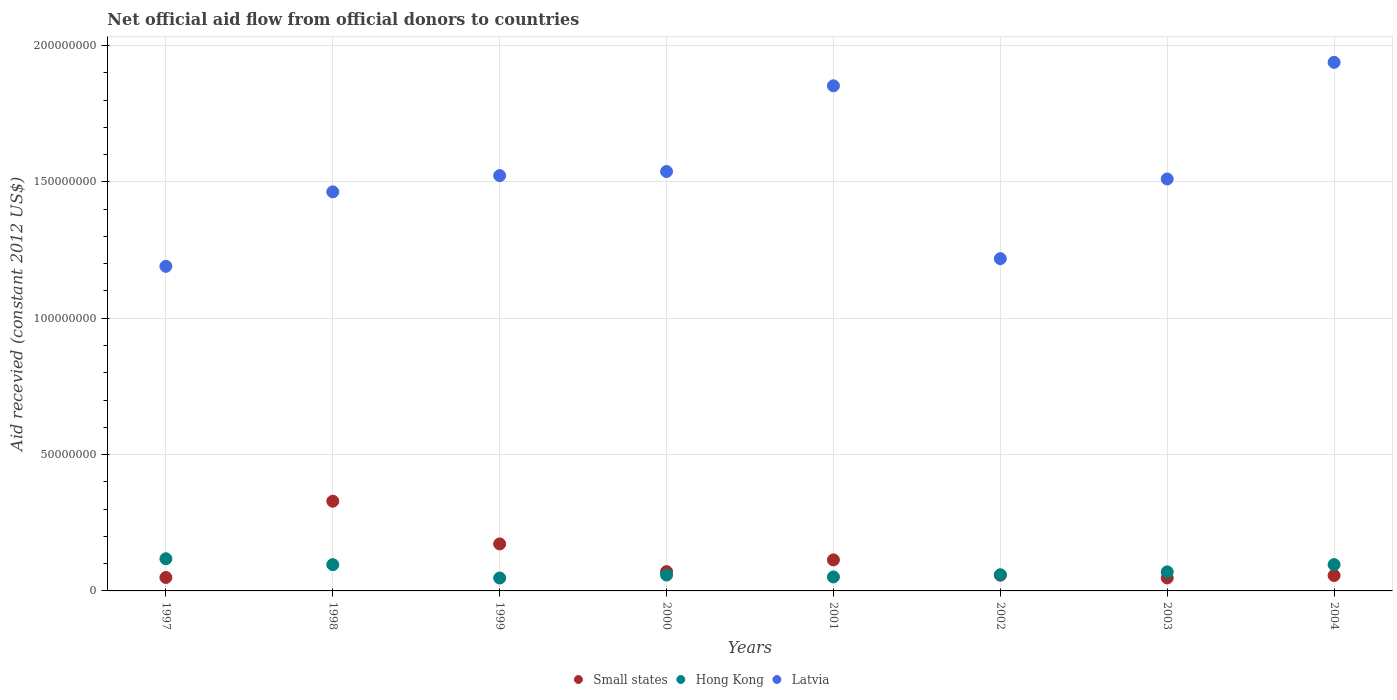How many different coloured dotlines are there?
Offer a very short reply. 3. What is the total aid received in Hong Kong in 2003?
Make the answer very short. 6.99e+06. Across all years, what is the maximum total aid received in Small states?
Your response must be concise. 3.29e+07. Across all years, what is the minimum total aid received in Small states?
Provide a short and direct response. 4.76e+06. In which year was the total aid received in Hong Kong maximum?
Offer a terse response. 1997. In which year was the total aid received in Latvia minimum?
Keep it short and to the point. 1997. What is the total total aid received in Small states in the graph?
Your answer should be compact. 8.97e+07. What is the difference between the total aid received in Latvia in 1997 and that in 2000?
Provide a succinct answer. -3.48e+07. What is the difference between the total aid received in Small states in 2002 and the total aid received in Latvia in 2001?
Make the answer very short. -1.79e+08. What is the average total aid received in Hong Kong per year?
Your answer should be compact. 7.46e+06. In the year 2002, what is the difference between the total aid received in Hong Kong and total aid received in Latvia?
Provide a short and direct response. -1.16e+08. In how many years, is the total aid received in Latvia greater than 180000000 US$?
Keep it short and to the point. 2. What is the ratio of the total aid received in Latvia in 2001 to that in 2003?
Offer a very short reply. 1.23. What is the difference between the highest and the second highest total aid received in Hong Kong?
Your answer should be very brief. 2.15e+06. What is the difference between the highest and the lowest total aid received in Small states?
Your answer should be compact. 2.81e+07. Is the sum of the total aid received in Small states in 2002 and 2003 greater than the maximum total aid received in Hong Kong across all years?
Make the answer very short. No. Is it the case that in every year, the sum of the total aid received in Small states and total aid received in Hong Kong  is greater than the total aid received in Latvia?
Provide a short and direct response. No. Is the total aid received in Latvia strictly greater than the total aid received in Small states over the years?
Keep it short and to the point. Yes. How many years are there in the graph?
Your answer should be very brief. 8. Are the values on the major ticks of Y-axis written in scientific E-notation?
Offer a terse response. No. How many legend labels are there?
Provide a succinct answer. 3. What is the title of the graph?
Give a very brief answer. Net official aid flow from official donors to countries. What is the label or title of the Y-axis?
Keep it short and to the point. Aid recevied (constant 2012 US$). What is the Aid recevied (constant 2012 US$) in Small states in 1997?
Offer a terse response. 4.93e+06. What is the Aid recevied (constant 2012 US$) in Hong Kong in 1997?
Your response must be concise. 1.18e+07. What is the Aid recevied (constant 2012 US$) in Latvia in 1997?
Offer a very short reply. 1.19e+08. What is the Aid recevied (constant 2012 US$) of Small states in 1998?
Ensure brevity in your answer.  3.29e+07. What is the Aid recevied (constant 2012 US$) of Hong Kong in 1998?
Offer a very short reply. 9.64e+06. What is the Aid recevied (constant 2012 US$) of Latvia in 1998?
Make the answer very short. 1.46e+08. What is the Aid recevied (constant 2012 US$) in Small states in 1999?
Your answer should be very brief. 1.72e+07. What is the Aid recevied (constant 2012 US$) of Hong Kong in 1999?
Offer a terse response. 4.73e+06. What is the Aid recevied (constant 2012 US$) of Latvia in 1999?
Ensure brevity in your answer.  1.52e+08. What is the Aid recevied (constant 2012 US$) of Small states in 2000?
Provide a succinct answer. 7.08e+06. What is the Aid recevied (constant 2012 US$) of Hong Kong in 2000?
Offer a terse response. 5.83e+06. What is the Aid recevied (constant 2012 US$) in Latvia in 2000?
Offer a very short reply. 1.54e+08. What is the Aid recevied (constant 2012 US$) in Small states in 2001?
Your response must be concise. 1.14e+07. What is the Aid recevied (constant 2012 US$) of Hong Kong in 2001?
Offer a very short reply. 5.12e+06. What is the Aid recevied (constant 2012 US$) of Latvia in 2001?
Keep it short and to the point. 1.85e+08. What is the Aid recevied (constant 2012 US$) of Small states in 2002?
Make the answer very short. 5.78e+06. What is the Aid recevied (constant 2012 US$) of Hong Kong in 2002?
Keep it short and to the point. 5.92e+06. What is the Aid recevied (constant 2012 US$) of Latvia in 2002?
Provide a short and direct response. 1.22e+08. What is the Aid recevied (constant 2012 US$) of Small states in 2003?
Make the answer very short. 4.76e+06. What is the Aid recevied (constant 2012 US$) in Hong Kong in 2003?
Ensure brevity in your answer.  6.99e+06. What is the Aid recevied (constant 2012 US$) of Latvia in 2003?
Your answer should be very brief. 1.51e+08. What is the Aid recevied (constant 2012 US$) of Small states in 2004?
Offer a terse response. 5.66e+06. What is the Aid recevied (constant 2012 US$) in Hong Kong in 2004?
Ensure brevity in your answer.  9.65e+06. What is the Aid recevied (constant 2012 US$) of Latvia in 2004?
Offer a terse response. 1.94e+08. Across all years, what is the maximum Aid recevied (constant 2012 US$) of Small states?
Provide a succinct answer. 3.29e+07. Across all years, what is the maximum Aid recevied (constant 2012 US$) of Hong Kong?
Give a very brief answer. 1.18e+07. Across all years, what is the maximum Aid recevied (constant 2012 US$) in Latvia?
Make the answer very short. 1.94e+08. Across all years, what is the minimum Aid recevied (constant 2012 US$) in Small states?
Offer a terse response. 4.76e+06. Across all years, what is the minimum Aid recevied (constant 2012 US$) of Hong Kong?
Give a very brief answer. 4.73e+06. Across all years, what is the minimum Aid recevied (constant 2012 US$) of Latvia?
Make the answer very short. 1.19e+08. What is the total Aid recevied (constant 2012 US$) in Small states in the graph?
Your response must be concise. 8.97e+07. What is the total Aid recevied (constant 2012 US$) in Hong Kong in the graph?
Offer a terse response. 5.97e+07. What is the total Aid recevied (constant 2012 US$) in Latvia in the graph?
Your answer should be very brief. 1.22e+09. What is the difference between the Aid recevied (constant 2012 US$) of Small states in 1997 and that in 1998?
Your answer should be compact. -2.80e+07. What is the difference between the Aid recevied (constant 2012 US$) of Hong Kong in 1997 and that in 1998?
Your response must be concise. 2.16e+06. What is the difference between the Aid recevied (constant 2012 US$) of Latvia in 1997 and that in 1998?
Ensure brevity in your answer.  -2.73e+07. What is the difference between the Aid recevied (constant 2012 US$) of Small states in 1997 and that in 1999?
Your answer should be compact. -1.23e+07. What is the difference between the Aid recevied (constant 2012 US$) in Hong Kong in 1997 and that in 1999?
Your answer should be compact. 7.07e+06. What is the difference between the Aid recevied (constant 2012 US$) of Latvia in 1997 and that in 1999?
Offer a terse response. -3.33e+07. What is the difference between the Aid recevied (constant 2012 US$) in Small states in 1997 and that in 2000?
Offer a terse response. -2.15e+06. What is the difference between the Aid recevied (constant 2012 US$) of Hong Kong in 1997 and that in 2000?
Offer a very short reply. 5.97e+06. What is the difference between the Aid recevied (constant 2012 US$) of Latvia in 1997 and that in 2000?
Provide a short and direct response. -3.48e+07. What is the difference between the Aid recevied (constant 2012 US$) in Small states in 1997 and that in 2001?
Make the answer very short. -6.45e+06. What is the difference between the Aid recevied (constant 2012 US$) in Hong Kong in 1997 and that in 2001?
Offer a very short reply. 6.68e+06. What is the difference between the Aid recevied (constant 2012 US$) of Latvia in 1997 and that in 2001?
Ensure brevity in your answer.  -6.62e+07. What is the difference between the Aid recevied (constant 2012 US$) in Small states in 1997 and that in 2002?
Your response must be concise. -8.50e+05. What is the difference between the Aid recevied (constant 2012 US$) of Hong Kong in 1997 and that in 2002?
Offer a terse response. 5.88e+06. What is the difference between the Aid recevied (constant 2012 US$) of Latvia in 1997 and that in 2002?
Offer a very short reply. -2.81e+06. What is the difference between the Aid recevied (constant 2012 US$) of Small states in 1997 and that in 2003?
Keep it short and to the point. 1.70e+05. What is the difference between the Aid recevied (constant 2012 US$) of Hong Kong in 1997 and that in 2003?
Provide a short and direct response. 4.81e+06. What is the difference between the Aid recevied (constant 2012 US$) of Latvia in 1997 and that in 2003?
Your response must be concise. -3.20e+07. What is the difference between the Aid recevied (constant 2012 US$) in Small states in 1997 and that in 2004?
Your answer should be very brief. -7.30e+05. What is the difference between the Aid recevied (constant 2012 US$) in Hong Kong in 1997 and that in 2004?
Your answer should be very brief. 2.15e+06. What is the difference between the Aid recevied (constant 2012 US$) in Latvia in 1997 and that in 2004?
Keep it short and to the point. -7.48e+07. What is the difference between the Aid recevied (constant 2012 US$) of Small states in 1998 and that in 1999?
Your response must be concise. 1.57e+07. What is the difference between the Aid recevied (constant 2012 US$) in Hong Kong in 1998 and that in 1999?
Give a very brief answer. 4.91e+06. What is the difference between the Aid recevied (constant 2012 US$) of Latvia in 1998 and that in 1999?
Your response must be concise. -5.96e+06. What is the difference between the Aid recevied (constant 2012 US$) in Small states in 1998 and that in 2000?
Your answer should be compact. 2.58e+07. What is the difference between the Aid recevied (constant 2012 US$) of Hong Kong in 1998 and that in 2000?
Provide a succinct answer. 3.81e+06. What is the difference between the Aid recevied (constant 2012 US$) in Latvia in 1998 and that in 2000?
Give a very brief answer. -7.46e+06. What is the difference between the Aid recevied (constant 2012 US$) of Small states in 1998 and that in 2001?
Offer a very short reply. 2.15e+07. What is the difference between the Aid recevied (constant 2012 US$) of Hong Kong in 1998 and that in 2001?
Make the answer very short. 4.52e+06. What is the difference between the Aid recevied (constant 2012 US$) in Latvia in 1998 and that in 2001?
Make the answer very short. -3.89e+07. What is the difference between the Aid recevied (constant 2012 US$) of Small states in 1998 and that in 2002?
Your answer should be compact. 2.71e+07. What is the difference between the Aid recevied (constant 2012 US$) of Hong Kong in 1998 and that in 2002?
Your answer should be compact. 3.72e+06. What is the difference between the Aid recevied (constant 2012 US$) in Latvia in 1998 and that in 2002?
Provide a short and direct response. 2.45e+07. What is the difference between the Aid recevied (constant 2012 US$) in Small states in 1998 and that in 2003?
Offer a very short reply. 2.81e+07. What is the difference between the Aid recevied (constant 2012 US$) of Hong Kong in 1998 and that in 2003?
Your answer should be compact. 2.65e+06. What is the difference between the Aid recevied (constant 2012 US$) of Latvia in 1998 and that in 2003?
Keep it short and to the point. -4.72e+06. What is the difference between the Aid recevied (constant 2012 US$) in Small states in 1998 and that in 2004?
Offer a terse response. 2.72e+07. What is the difference between the Aid recevied (constant 2012 US$) of Latvia in 1998 and that in 2004?
Give a very brief answer. -4.75e+07. What is the difference between the Aid recevied (constant 2012 US$) of Small states in 1999 and that in 2000?
Your response must be concise. 1.02e+07. What is the difference between the Aid recevied (constant 2012 US$) in Hong Kong in 1999 and that in 2000?
Provide a short and direct response. -1.10e+06. What is the difference between the Aid recevied (constant 2012 US$) in Latvia in 1999 and that in 2000?
Offer a very short reply. -1.50e+06. What is the difference between the Aid recevied (constant 2012 US$) in Small states in 1999 and that in 2001?
Offer a very short reply. 5.86e+06. What is the difference between the Aid recevied (constant 2012 US$) in Hong Kong in 1999 and that in 2001?
Provide a short and direct response. -3.90e+05. What is the difference between the Aid recevied (constant 2012 US$) in Latvia in 1999 and that in 2001?
Offer a very short reply. -3.29e+07. What is the difference between the Aid recevied (constant 2012 US$) of Small states in 1999 and that in 2002?
Ensure brevity in your answer.  1.15e+07. What is the difference between the Aid recevied (constant 2012 US$) of Hong Kong in 1999 and that in 2002?
Provide a short and direct response. -1.19e+06. What is the difference between the Aid recevied (constant 2012 US$) of Latvia in 1999 and that in 2002?
Provide a short and direct response. 3.05e+07. What is the difference between the Aid recevied (constant 2012 US$) of Small states in 1999 and that in 2003?
Offer a terse response. 1.25e+07. What is the difference between the Aid recevied (constant 2012 US$) of Hong Kong in 1999 and that in 2003?
Your response must be concise. -2.26e+06. What is the difference between the Aid recevied (constant 2012 US$) of Latvia in 1999 and that in 2003?
Offer a very short reply. 1.24e+06. What is the difference between the Aid recevied (constant 2012 US$) in Small states in 1999 and that in 2004?
Offer a very short reply. 1.16e+07. What is the difference between the Aid recevied (constant 2012 US$) of Hong Kong in 1999 and that in 2004?
Offer a very short reply. -4.92e+06. What is the difference between the Aid recevied (constant 2012 US$) of Latvia in 1999 and that in 2004?
Your answer should be very brief. -4.15e+07. What is the difference between the Aid recevied (constant 2012 US$) in Small states in 2000 and that in 2001?
Keep it short and to the point. -4.30e+06. What is the difference between the Aid recevied (constant 2012 US$) in Hong Kong in 2000 and that in 2001?
Ensure brevity in your answer.  7.10e+05. What is the difference between the Aid recevied (constant 2012 US$) of Latvia in 2000 and that in 2001?
Your answer should be compact. -3.14e+07. What is the difference between the Aid recevied (constant 2012 US$) of Small states in 2000 and that in 2002?
Your response must be concise. 1.30e+06. What is the difference between the Aid recevied (constant 2012 US$) in Latvia in 2000 and that in 2002?
Your response must be concise. 3.20e+07. What is the difference between the Aid recevied (constant 2012 US$) of Small states in 2000 and that in 2003?
Offer a terse response. 2.32e+06. What is the difference between the Aid recevied (constant 2012 US$) in Hong Kong in 2000 and that in 2003?
Provide a succinct answer. -1.16e+06. What is the difference between the Aid recevied (constant 2012 US$) in Latvia in 2000 and that in 2003?
Give a very brief answer. 2.74e+06. What is the difference between the Aid recevied (constant 2012 US$) in Small states in 2000 and that in 2004?
Provide a short and direct response. 1.42e+06. What is the difference between the Aid recevied (constant 2012 US$) of Hong Kong in 2000 and that in 2004?
Provide a short and direct response. -3.82e+06. What is the difference between the Aid recevied (constant 2012 US$) of Latvia in 2000 and that in 2004?
Offer a terse response. -4.00e+07. What is the difference between the Aid recevied (constant 2012 US$) of Small states in 2001 and that in 2002?
Offer a very short reply. 5.60e+06. What is the difference between the Aid recevied (constant 2012 US$) of Hong Kong in 2001 and that in 2002?
Make the answer very short. -8.00e+05. What is the difference between the Aid recevied (constant 2012 US$) in Latvia in 2001 and that in 2002?
Make the answer very short. 6.34e+07. What is the difference between the Aid recevied (constant 2012 US$) in Small states in 2001 and that in 2003?
Your answer should be very brief. 6.62e+06. What is the difference between the Aid recevied (constant 2012 US$) in Hong Kong in 2001 and that in 2003?
Your answer should be very brief. -1.87e+06. What is the difference between the Aid recevied (constant 2012 US$) in Latvia in 2001 and that in 2003?
Offer a terse response. 3.42e+07. What is the difference between the Aid recevied (constant 2012 US$) of Small states in 2001 and that in 2004?
Your answer should be compact. 5.72e+06. What is the difference between the Aid recevied (constant 2012 US$) in Hong Kong in 2001 and that in 2004?
Your answer should be very brief. -4.53e+06. What is the difference between the Aid recevied (constant 2012 US$) in Latvia in 2001 and that in 2004?
Give a very brief answer. -8.60e+06. What is the difference between the Aid recevied (constant 2012 US$) in Small states in 2002 and that in 2003?
Ensure brevity in your answer.  1.02e+06. What is the difference between the Aid recevied (constant 2012 US$) of Hong Kong in 2002 and that in 2003?
Provide a succinct answer. -1.07e+06. What is the difference between the Aid recevied (constant 2012 US$) of Latvia in 2002 and that in 2003?
Keep it short and to the point. -2.92e+07. What is the difference between the Aid recevied (constant 2012 US$) in Hong Kong in 2002 and that in 2004?
Ensure brevity in your answer.  -3.73e+06. What is the difference between the Aid recevied (constant 2012 US$) of Latvia in 2002 and that in 2004?
Provide a short and direct response. -7.20e+07. What is the difference between the Aid recevied (constant 2012 US$) in Small states in 2003 and that in 2004?
Give a very brief answer. -9.00e+05. What is the difference between the Aid recevied (constant 2012 US$) of Hong Kong in 2003 and that in 2004?
Offer a terse response. -2.66e+06. What is the difference between the Aid recevied (constant 2012 US$) of Latvia in 2003 and that in 2004?
Your answer should be compact. -4.28e+07. What is the difference between the Aid recevied (constant 2012 US$) in Small states in 1997 and the Aid recevied (constant 2012 US$) in Hong Kong in 1998?
Make the answer very short. -4.71e+06. What is the difference between the Aid recevied (constant 2012 US$) in Small states in 1997 and the Aid recevied (constant 2012 US$) in Latvia in 1998?
Ensure brevity in your answer.  -1.41e+08. What is the difference between the Aid recevied (constant 2012 US$) in Hong Kong in 1997 and the Aid recevied (constant 2012 US$) in Latvia in 1998?
Your response must be concise. -1.35e+08. What is the difference between the Aid recevied (constant 2012 US$) in Small states in 1997 and the Aid recevied (constant 2012 US$) in Latvia in 1999?
Provide a succinct answer. -1.47e+08. What is the difference between the Aid recevied (constant 2012 US$) of Hong Kong in 1997 and the Aid recevied (constant 2012 US$) of Latvia in 1999?
Provide a short and direct response. -1.41e+08. What is the difference between the Aid recevied (constant 2012 US$) of Small states in 1997 and the Aid recevied (constant 2012 US$) of Hong Kong in 2000?
Ensure brevity in your answer.  -9.00e+05. What is the difference between the Aid recevied (constant 2012 US$) in Small states in 1997 and the Aid recevied (constant 2012 US$) in Latvia in 2000?
Make the answer very short. -1.49e+08. What is the difference between the Aid recevied (constant 2012 US$) of Hong Kong in 1997 and the Aid recevied (constant 2012 US$) of Latvia in 2000?
Make the answer very short. -1.42e+08. What is the difference between the Aid recevied (constant 2012 US$) in Small states in 1997 and the Aid recevied (constant 2012 US$) in Latvia in 2001?
Offer a terse response. -1.80e+08. What is the difference between the Aid recevied (constant 2012 US$) in Hong Kong in 1997 and the Aid recevied (constant 2012 US$) in Latvia in 2001?
Your answer should be compact. -1.73e+08. What is the difference between the Aid recevied (constant 2012 US$) of Small states in 1997 and the Aid recevied (constant 2012 US$) of Hong Kong in 2002?
Offer a very short reply. -9.90e+05. What is the difference between the Aid recevied (constant 2012 US$) in Small states in 1997 and the Aid recevied (constant 2012 US$) in Latvia in 2002?
Your answer should be very brief. -1.17e+08. What is the difference between the Aid recevied (constant 2012 US$) of Hong Kong in 1997 and the Aid recevied (constant 2012 US$) of Latvia in 2002?
Ensure brevity in your answer.  -1.10e+08. What is the difference between the Aid recevied (constant 2012 US$) of Small states in 1997 and the Aid recevied (constant 2012 US$) of Hong Kong in 2003?
Provide a succinct answer. -2.06e+06. What is the difference between the Aid recevied (constant 2012 US$) in Small states in 1997 and the Aid recevied (constant 2012 US$) in Latvia in 2003?
Your answer should be very brief. -1.46e+08. What is the difference between the Aid recevied (constant 2012 US$) of Hong Kong in 1997 and the Aid recevied (constant 2012 US$) of Latvia in 2003?
Keep it short and to the point. -1.39e+08. What is the difference between the Aid recevied (constant 2012 US$) in Small states in 1997 and the Aid recevied (constant 2012 US$) in Hong Kong in 2004?
Keep it short and to the point. -4.72e+06. What is the difference between the Aid recevied (constant 2012 US$) in Small states in 1997 and the Aid recevied (constant 2012 US$) in Latvia in 2004?
Provide a short and direct response. -1.89e+08. What is the difference between the Aid recevied (constant 2012 US$) in Hong Kong in 1997 and the Aid recevied (constant 2012 US$) in Latvia in 2004?
Give a very brief answer. -1.82e+08. What is the difference between the Aid recevied (constant 2012 US$) of Small states in 1998 and the Aid recevied (constant 2012 US$) of Hong Kong in 1999?
Provide a short and direct response. 2.82e+07. What is the difference between the Aid recevied (constant 2012 US$) of Small states in 1998 and the Aid recevied (constant 2012 US$) of Latvia in 1999?
Your answer should be compact. -1.19e+08. What is the difference between the Aid recevied (constant 2012 US$) of Hong Kong in 1998 and the Aid recevied (constant 2012 US$) of Latvia in 1999?
Keep it short and to the point. -1.43e+08. What is the difference between the Aid recevied (constant 2012 US$) of Small states in 1998 and the Aid recevied (constant 2012 US$) of Hong Kong in 2000?
Your answer should be compact. 2.71e+07. What is the difference between the Aid recevied (constant 2012 US$) in Small states in 1998 and the Aid recevied (constant 2012 US$) in Latvia in 2000?
Ensure brevity in your answer.  -1.21e+08. What is the difference between the Aid recevied (constant 2012 US$) of Hong Kong in 1998 and the Aid recevied (constant 2012 US$) of Latvia in 2000?
Keep it short and to the point. -1.44e+08. What is the difference between the Aid recevied (constant 2012 US$) in Small states in 1998 and the Aid recevied (constant 2012 US$) in Hong Kong in 2001?
Keep it short and to the point. 2.78e+07. What is the difference between the Aid recevied (constant 2012 US$) of Small states in 1998 and the Aid recevied (constant 2012 US$) of Latvia in 2001?
Offer a very short reply. -1.52e+08. What is the difference between the Aid recevied (constant 2012 US$) of Hong Kong in 1998 and the Aid recevied (constant 2012 US$) of Latvia in 2001?
Your answer should be very brief. -1.76e+08. What is the difference between the Aid recevied (constant 2012 US$) in Small states in 1998 and the Aid recevied (constant 2012 US$) in Hong Kong in 2002?
Provide a succinct answer. 2.70e+07. What is the difference between the Aid recevied (constant 2012 US$) of Small states in 1998 and the Aid recevied (constant 2012 US$) of Latvia in 2002?
Provide a short and direct response. -8.90e+07. What is the difference between the Aid recevied (constant 2012 US$) of Hong Kong in 1998 and the Aid recevied (constant 2012 US$) of Latvia in 2002?
Your answer should be very brief. -1.12e+08. What is the difference between the Aid recevied (constant 2012 US$) in Small states in 1998 and the Aid recevied (constant 2012 US$) in Hong Kong in 2003?
Offer a terse response. 2.59e+07. What is the difference between the Aid recevied (constant 2012 US$) of Small states in 1998 and the Aid recevied (constant 2012 US$) of Latvia in 2003?
Offer a very short reply. -1.18e+08. What is the difference between the Aid recevied (constant 2012 US$) in Hong Kong in 1998 and the Aid recevied (constant 2012 US$) in Latvia in 2003?
Your answer should be very brief. -1.41e+08. What is the difference between the Aid recevied (constant 2012 US$) of Small states in 1998 and the Aid recevied (constant 2012 US$) of Hong Kong in 2004?
Make the answer very short. 2.32e+07. What is the difference between the Aid recevied (constant 2012 US$) of Small states in 1998 and the Aid recevied (constant 2012 US$) of Latvia in 2004?
Give a very brief answer. -1.61e+08. What is the difference between the Aid recevied (constant 2012 US$) in Hong Kong in 1998 and the Aid recevied (constant 2012 US$) in Latvia in 2004?
Give a very brief answer. -1.84e+08. What is the difference between the Aid recevied (constant 2012 US$) in Small states in 1999 and the Aid recevied (constant 2012 US$) in Hong Kong in 2000?
Make the answer very short. 1.14e+07. What is the difference between the Aid recevied (constant 2012 US$) in Small states in 1999 and the Aid recevied (constant 2012 US$) in Latvia in 2000?
Make the answer very short. -1.37e+08. What is the difference between the Aid recevied (constant 2012 US$) in Hong Kong in 1999 and the Aid recevied (constant 2012 US$) in Latvia in 2000?
Provide a succinct answer. -1.49e+08. What is the difference between the Aid recevied (constant 2012 US$) of Small states in 1999 and the Aid recevied (constant 2012 US$) of Hong Kong in 2001?
Offer a terse response. 1.21e+07. What is the difference between the Aid recevied (constant 2012 US$) in Small states in 1999 and the Aid recevied (constant 2012 US$) in Latvia in 2001?
Offer a very short reply. -1.68e+08. What is the difference between the Aid recevied (constant 2012 US$) in Hong Kong in 1999 and the Aid recevied (constant 2012 US$) in Latvia in 2001?
Your response must be concise. -1.81e+08. What is the difference between the Aid recevied (constant 2012 US$) of Small states in 1999 and the Aid recevied (constant 2012 US$) of Hong Kong in 2002?
Offer a very short reply. 1.13e+07. What is the difference between the Aid recevied (constant 2012 US$) in Small states in 1999 and the Aid recevied (constant 2012 US$) in Latvia in 2002?
Provide a short and direct response. -1.05e+08. What is the difference between the Aid recevied (constant 2012 US$) of Hong Kong in 1999 and the Aid recevied (constant 2012 US$) of Latvia in 2002?
Ensure brevity in your answer.  -1.17e+08. What is the difference between the Aid recevied (constant 2012 US$) in Small states in 1999 and the Aid recevied (constant 2012 US$) in Hong Kong in 2003?
Your response must be concise. 1.02e+07. What is the difference between the Aid recevied (constant 2012 US$) in Small states in 1999 and the Aid recevied (constant 2012 US$) in Latvia in 2003?
Keep it short and to the point. -1.34e+08. What is the difference between the Aid recevied (constant 2012 US$) of Hong Kong in 1999 and the Aid recevied (constant 2012 US$) of Latvia in 2003?
Make the answer very short. -1.46e+08. What is the difference between the Aid recevied (constant 2012 US$) of Small states in 1999 and the Aid recevied (constant 2012 US$) of Hong Kong in 2004?
Provide a short and direct response. 7.59e+06. What is the difference between the Aid recevied (constant 2012 US$) in Small states in 1999 and the Aid recevied (constant 2012 US$) in Latvia in 2004?
Your response must be concise. -1.77e+08. What is the difference between the Aid recevied (constant 2012 US$) of Hong Kong in 1999 and the Aid recevied (constant 2012 US$) of Latvia in 2004?
Offer a terse response. -1.89e+08. What is the difference between the Aid recevied (constant 2012 US$) of Small states in 2000 and the Aid recevied (constant 2012 US$) of Hong Kong in 2001?
Ensure brevity in your answer.  1.96e+06. What is the difference between the Aid recevied (constant 2012 US$) in Small states in 2000 and the Aid recevied (constant 2012 US$) in Latvia in 2001?
Give a very brief answer. -1.78e+08. What is the difference between the Aid recevied (constant 2012 US$) of Hong Kong in 2000 and the Aid recevied (constant 2012 US$) of Latvia in 2001?
Your answer should be very brief. -1.79e+08. What is the difference between the Aid recevied (constant 2012 US$) of Small states in 2000 and the Aid recevied (constant 2012 US$) of Hong Kong in 2002?
Keep it short and to the point. 1.16e+06. What is the difference between the Aid recevied (constant 2012 US$) in Small states in 2000 and the Aid recevied (constant 2012 US$) in Latvia in 2002?
Give a very brief answer. -1.15e+08. What is the difference between the Aid recevied (constant 2012 US$) in Hong Kong in 2000 and the Aid recevied (constant 2012 US$) in Latvia in 2002?
Make the answer very short. -1.16e+08. What is the difference between the Aid recevied (constant 2012 US$) in Small states in 2000 and the Aid recevied (constant 2012 US$) in Latvia in 2003?
Provide a succinct answer. -1.44e+08. What is the difference between the Aid recevied (constant 2012 US$) in Hong Kong in 2000 and the Aid recevied (constant 2012 US$) in Latvia in 2003?
Ensure brevity in your answer.  -1.45e+08. What is the difference between the Aid recevied (constant 2012 US$) in Small states in 2000 and the Aid recevied (constant 2012 US$) in Hong Kong in 2004?
Offer a very short reply. -2.57e+06. What is the difference between the Aid recevied (constant 2012 US$) in Small states in 2000 and the Aid recevied (constant 2012 US$) in Latvia in 2004?
Provide a succinct answer. -1.87e+08. What is the difference between the Aid recevied (constant 2012 US$) in Hong Kong in 2000 and the Aid recevied (constant 2012 US$) in Latvia in 2004?
Provide a short and direct response. -1.88e+08. What is the difference between the Aid recevied (constant 2012 US$) of Small states in 2001 and the Aid recevied (constant 2012 US$) of Hong Kong in 2002?
Your answer should be very brief. 5.46e+06. What is the difference between the Aid recevied (constant 2012 US$) in Small states in 2001 and the Aid recevied (constant 2012 US$) in Latvia in 2002?
Make the answer very short. -1.10e+08. What is the difference between the Aid recevied (constant 2012 US$) of Hong Kong in 2001 and the Aid recevied (constant 2012 US$) of Latvia in 2002?
Offer a very short reply. -1.17e+08. What is the difference between the Aid recevied (constant 2012 US$) in Small states in 2001 and the Aid recevied (constant 2012 US$) in Hong Kong in 2003?
Provide a short and direct response. 4.39e+06. What is the difference between the Aid recevied (constant 2012 US$) of Small states in 2001 and the Aid recevied (constant 2012 US$) of Latvia in 2003?
Keep it short and to the point. -1.40e+08. What is the difference between the Aid recevied (constant 2012 US$) in Hong Kong in 2001 and the Aid recevied (constant 2012 US$) in Latvia in 2003?
Your answer should be very brief. -1.46e+08. What is the difference between the Aid recevied (constant 2012 US$) in Small states in 2001 and the Aid recevied (constant 2012 US$) in Hong Kong in 2004?
Make the answer very short. 1.73e+06. What is the difference between the Aid recevied (constant 2012 US$) of Small states in 2001 and the Aid recevied (constant 2012 US$) of Latvia in 2004?
Your answer should be very brief. -1.82e+08. What is the difference between the Aid recevied (constant 2012 US$) in Hong Kong in 2001 and the Aid recevied (constant 2012 US$) in Latvia in 2004?
Your answer should be compact. -1.89e+08. What is the difference between the Aid recevied (constant 2012 US$) of Small states in 2002 and the Aid recevied (constant 2012 US$) of Hong Kong in 2003?
Provide a succinct answer. -1.21e+06. What is the difference between the Aid recevied (constant 2012 US$) of Small states in 2002 and the Aid recevied (constant 2012 US$) of Latvia in 2003?
Provide a succinct answer. -1.45e+08. What is the difference between the Aid recevied (constant 2012 US$) of Hong Kong in 2002 and the Aid recevied (constant 2012 US$) of Latvia in 2003?
Your response must be concise. -1.45e+08. What is the difference between the Aid recevied (constant 2012 US$) in Small states in 2002 and the Aid recevied (constant 2012 US$) in Hong Kong in 2004?
Keep it short and to the point. -3.87e+06. What is the difference between the Aid recevied (constant 2012 US$) in Small states in 2002 and the Aid recevied (constant 2012 US$) in Latvia in 2004?
Make the answer very short. -1.88e+08. What is the difference between the Aid recevied (constant 2012 US$) in Hong Kong in 2002 and the Aid recevied (constant 2012 US$) in Latvia in 2004?
Provide a succinct answer. -1.88e+08. What is the difference between the Aid recevied (constant 2012 US$) of Small states in 2003 and the Aid recevied (constant 2012 US$) of Hong Kong in 2004?
Your response must be concise. -4.89e+06. What is the difference between the Aid recevied (constant 2012 US$) of Small states in 2003 and the Aid recevied (constant 2012 US$) of Latvia in 2004?
Your response must be concise. -1.89e+08. What is the difference between the Aid recevied (constant 2012 US$) in Hong Kong in 2003 and the Aid recevied (constant 2012 US$) in Latvia in 2004?
Ensure brevity in your answer.  -1.87e+08. What is the average Aid recevied (constant 2012 US$) in Small states per year?
Give a very brief answer. 1.12e+07. What is the average Aid recevied (constant 2012 US$) in Hong Kong per year?
Provide a short and direct response. 7.46e+06. What is the average Aid recevied (constant 2012 US$) in Latvia per year?
Offer a very short reply. 1.53e+08. In the year 1997, what is the difference between the Aid recevied (constant 2012 US$) of Small states and Aid recevied (constant 2012 US$) of Hong Kong?
Your response must be concise. -6.87e+06. In the year 1997, what is the difference between the Aid recevied (constant 2012 US$) of Small states and Aid recevied (constant 2012 US$) of Latvia?
Provide a succinct answer. -1.14e+08. In the year 1997, what is the difference between the Aid recevied (constant 2012 US$) in Hong Kong and Aid recevied (constant 2012 US$) in Latvia?
Your answer should be very brief. -1.07e+08. In the year 1998, what is the difference between the Aid recevied (constant 2012 US$) of Small states and Aid recevied (constant 2012 US$) of Hong Kong?
Provide a succinct answer. 2.33e+07. In the year 1998, what is the difference between the Aid recevied (constant 2012 US$) of Small states and Aid recevied (constant 2012 US$) of Latvia?
Your response must be concise. -1.13e+08. In the year 1998, what is the difference between the Aid recevied (constant 2012 US$) in Hong Kong and Aid recevied (constant 2012 US$) in Latvia?
Provide a succinct answer. -1.37e+08. In the year 1999, what is the difference between the Aid recevied (constant 2012 US$) of Small states and Aid recevied (constant 2012 US$) of Hong Kong?
Offer a terse response. 1.25e+07. In the year 1999, what is the difference between the Aid recevied (constant 2012 US$) of Small states and Aid recevied (constant 2012 US$) of Latvia?
Your response must be concise. -1.35e+08. In the year 1999, what is the difference between the Aid recevied (constant 2012 US$) of Hong Kong and Aid recevied (constant 2012 US$) of Latvia?
Your response must be concise. -1.48e+08. In the year 2000, what is the difference between the Aid recevied (constant 2012 US$) of Small states and Aid recevied (constant 2012 US$) of Hong Kong?
Provide a short and direct response. 1.25e+06. In the year 2000, what is the difference between the Aid recevied (constant 2012 US$) in Small states and Aid recevied (constant 2012 US$) in Latvia?
Your answer should be compact. -1.47e+08. In the year 2000, what is the difference between the Aid recevied (constant 2012 US$) of Hong Kong and Aid recevied (constant 2012 US$) of Latvia?
Ensure brevity in your answer.  -1.48e+08. In the year 2001, what is the difference between the Aid recevied (constant 2012 US$) of Small states and Aid recevied (constant 2012 US$) of Hong Kong?
Your response must be concise. 6.26e+06. In the year 2001, what is the difference between the Aid recevied (constant 2012 US$) in Small states and Aid recevied (constant 2012 US$) in Latvia?
Make the answer very short. -1.74e+08. In the year 2001, what is the difference between the Aid recevied (constant 2012 US$) of Hong Kong and Aid recevied (constant 2012 US$) of Latvia?
Provide a short and direct response. -1.80e+08. In the year 2002, what is the difference between the Aid recevied (constant 2012 US$) of Small states and Aid recevied (constant 2012 US$) of Latvia?
Offer a terse response. -1.16e+08. In the year 2002, what is the difference between the Aid recevied (constant 2012 US$) in Hong Kong and Aid recevied (constant 2012 US$) in Latvia?
Give a very brief answer. -1.16e+08. In the year 2003, what is the difference between the Aid recevied (constant 2012 US$) in Small states and Aid recevied (constant 2012 US$) in Hong Kong?
Your answer should be very brief. -2.23e+06. In the year 2003, what is the difference between the Aid recevied (constant 2012 US$) of Small states and Aid recevied (constant 2012 US$) of Latvia?
Make the answer very short. -1.46e+08. In the year 2003, what is the difference between the Aid recevied (constant 2012 US$) in Hong Kong and Aid recevied (constant 2012 US$) in Latvia?
Keep it short and to the point. -1.44e+08. In the year 2004, what is the difference between the Aid recevied (constant 2012 US$) in Small states and Aid recevied (constant 2012 US$) in Hong Kong?
Give a very brief answer. -3.99e+06. In the year 2004, what is the difference between the Aid recevied (constant 2012 US$) of Small states and Aid recevied (constant 2012 US$) of Latvia?
Give a very brief answer. -1.88e+08. In the year 2004, what is the difference between the Aid recevied (constant 2012 US$) in Hong Kong and Aid recevied (constant 2012 US$) in Latvia?
Provide a succinct answer. -1.84e+08. What is the ratio of the Aid recevied (constant 2012 US$) in Small states in 1997 to that in 1998?
Your answer should be very brief. 0.15. What is the ratio of the Aid recevied (constant 2012 US$) in Hong Kong in 1997 to that in 1998?
Ensure brevity in your answer.  1.22. What is the ratio of the Aid recevied (constant 2012 US$) in Latvia in 1997 to that in 1998?
Offer a terse response. 0.81. What is the ratio of the Aid recevied (constant 2012 US$) in Small states in 1997 to that in 1999?
Offer a terse response. 0.29. What is the ratio of the Aid recevied (constant 2012 US$) in Hong Kong in 1997 to that in 1999?
Make the answer very short. 2.49. What is the ratio of the Aid recevied (constant 2012 US$) in Latvia in 1997 to that in 1999?
Make the answer very short. 0.78. What is the ratio of the Aid recevied (constant 2012 US$) of Small states in 1997 to that in 2000?
Make the answer very short. 0.7. What is the ratio of the Aid recevied (constant 2012 US$) of Hong Kong in 1997 to that in 2000?
Your answer should be compact. 2.02. What is the ratio of the Aid recevied (constant 2012 US$) in Latvia in 1997 to that in 2000?
Provide a succinct answer. 0.77. What is the ratio of the Aid recevied (constant 2012 US$) in Small states in 1997 to that in 2001?
Provide a short and direct response. 0.43. What is the ratio of the Aid recevied (constant 2012 US$) in Hong Kong in 1997 to that in 2001?
Offer a very short reply. 2.3. What is the ratio of the Aid recevied (constant 2012 US$) in Latvia in 1997 to that in 2001?
Keep it short and to the point. 0.64. What is the ratio of the Aid recevied (constant 2012 US$) in Small states in 1997 to that in 2002?
Your response must be concise. 0.85. What is the ratio of the Aid recevied (constant 2012 US$) of Hong Kong in 1997 to that in 2002?
Your answer should be compact. 1.99. What is the ratio of the Aid recevied (constant 2012 US$) of Latvia in 1997 to that in 2002?
Provide a succinct answer. 0.98. What is the ratio of the Aid recevied (constant 2012 US$) in Small states in 1997 to that in 2003?
Ensure brevity in your answer.  1.04. What is the ratio of the Aid recevied (constant 2012 US$) of Hong Kong in 1997 to that in 2003?
Provide a short and direct response. 1.69. What is the ratio of the Aid recevied (constant 2012 US$) of Latvia in 1997 to that in 2003?
Offer a very short reply. 0.79. What is the ratio of the Aid recevied (constant 2012 US$) of Small states in 1997 to that in 2004?
Your answer should be very brief. 0.87. What is the ratio of the Aid recevied (constant 2012 US$) of Hong Kong in 1997 to that in 2004?
Provide a succinct answer. 1.22. What is the ratio of the Aid recevied (constant 2012 US$) in Latvia in 1997 to that in 2004?
Provide a short and direct response. 0.61. What is the ratio of the Aid recevied (constant 2012 US$) of Small states in 1998 to that in 1999?
Give a very brief answer. 1.91. What is the ratio of the Aid recevied (constant 2012 US$) of Hong Kong in 1998 to that in 1999?
Keep it short and to the point. 2.04. What is the ratio of the Aid recevied (constant 2012 US$) in Latvia in 1998 to that in 1999?
Keep it short and to the point. 0.96. What is the ratio of the Aid recevied (constant 2012 US$) of Small states in 1998 to that in 2000?
Provide a succinct answer. 4.65. What is the ratio of the Aid recevied (constant 2012 US$) in Hong Kong in 1998 to that in 2000?
Provide a succinct answer. 1.65. What is the ratio of the Aid recevied (constant 2012 US$) of Latvia in 1998 to that in 2000?
Your answer should be compact. 0.95. What is the ratio of the Aid recevied (constant 2012 US$) in Small states in 1998 to that in 2001?
Your response must be concise. 2.89. What is the ratio of the Aid recevied (constant 2012 US$) of Hong Kong in 1998 to that in 2001?
Make the answer very short. 1.88. What is the ratio of the Aid recevied (constant 2012 US$) of Latvia in 1998 to that in 2001?
Keep it short and to the point. 0.79. What is the ratio of the Aid recevied (constant 2012 US$) of Small states in 1998 to that in 2002?
Keep it short and to the point. 5.69. What is the ratio of the Aid recevied (constant 2012 US$) of Hong Kong in 1998 to that in 2002?
Your response must be concise. 1.63. What is the ratio of the Aid recevied (constant 2012 US$) in Latvia in 1998 to that in 2002?
Offer a very short reply. 1.2. What is the ratio of the Aid recevied (constant 2012 US$) of Small states in 1998 to that in 2003?
Your answer should be compact. 6.91. What is the ratio of the Aid recevied (constant 2012 US$) of Hong Kong in 1998 to that in 2003?
Keep it short and to the point. 1.38. What is the ratio of the Aid recevied (constant 2012 US$) in Latvia in 1998 to that in 2003?
Ensure brevity in your answer.  0.97. What is the ratio of the Aid recevied (constant 2012 US$) of Small states in 1998 to that in 2004?
Give a very brief answer. 5.81. What is the ratio of the Aid recevied (constant 2012 US$) in Hong Kong in 1998 to that in 2004?
Your answer should be compact. 1. What is the ratio of the Aid recevied (constant 2012 US$) in Latvia in 1998 to that in 2004?
Your answer should be compact. 0.76. What is the ratio of the Aid recevied (constant 2012 US$) in Small states in 1999 to that in 2000?
Ensure brevity in your answer.  2.44. What is the ratio of the Aid recevied (constant 2012 US$) of Hong Kong in 1999 to that in 2000?
Keep it short and to the point. 0.81. What is the ratio of the Aid recevied (constant 2012 US$) in Latvia in 1999 to that in 2000?
Provide a short and direct response. 0.99. What is the ratio of the Aid recevied (constant 2012 US$) in Small states in 1999 to that in 2001?
Make the answer very short. 1.51. What is the ratio of the Aid recevied (constant 2012 US$) in Hong Kong in 1999 to that in 2001?
Your response must be concise. 0.92. What is the ratio of the Aid recevied (constant 2012 US$) of Latvia in 1999 to that in 2001?
Provide a short and direct response. 0.82. What is the ratio of the Aid recevied (constant 2012 US$) of Small states in 1999 to that in 2002?
Keep it short and to the point. 2.98. What is the ratio of the Aid recevied (constant 2012 US$) in Hong Kong in 1999 to that in 2002?
Your answer should be very brief. 0.8. What is the ratio of the Aid recevied (constant 2012 US$) in Latvia in 1999 to that in 2002?
Ensure brevity in your answer.  1.25. What is the ratio of the Aid recevied (constant 2012 US$) in Small states in 1999 to that in 2003?
Make the answer very short. 3.62. What is the ratio of the Aid recevied (constant 2012 US$) of Hong Kong in 1999 to that in 2003?
Offer a terse response. 0.68. What is the ratio of the Aid recevied (constant 2012 US$) of Latvia in 1999 to that in 2003?
Provide a short and direct response. 1.01. What is the ratio of the Aid recevied (constant 2012 US$) of Small states in 1999 to that in 2004?
Your response must be concise. 3.05. What is the ratio of the Aid recevied (constant 2012 US$) of Hong Kong in 1999 to that in 2004?
Provide a short and direct response. 0.49. What is the ratio of the Aid recevied (constant 2012 US$) of Latvia in 1999 to that in 2004?
Ensure brevity in your answer.  0.79. What is the ratio of the Aid recevied (constant 2012 US$) in Small states in 2000 to that in 2001?
Offer a terse response. 0.62. What is the ratio of the Aid recevied (constant 2012 US$) of Hong Kong in 2000 to that in 2001?
Offer a terse response. 1.14. What is the ratio of the Aid recevied (constant 2012 US$) in Latvia in 2000 to that in 2001?
Keep it short and to the point. 0.83. What is the ratio of the Aid recevied (constant 2012 US$) in Small states in 2000 to that in 2002?
Your answer should be compact. 1.22. What is the ratio of the Aid recevied (constant 2012 US$) of Latvia in 2000 to that in 2002?
Offer a terse response. 1.26. What is the ratio of the Aid recevied (constant 2012 US$) in Small states in 2000 to that in 2003?
Your answer should be very brief. 1.49. What is the ratio of the Aid recevied (constant 2012 US$) of Hong Kong in 2000 to that in 2003?
Keep it short and to the point. 0.83. What is the ratio of the Aid recevied (constant 2012 US$) of Latvia in 2000 to that in 2003?
Offer a terse response. 1.02. What is the ratio of the Aid recevied (constant 2012 US$) in Small states in 2000 to that in 2004?
Your response must be concise. 1.25. What is the ratio of the Aid recevied (constant 2012 US$) of Hong Kong in 2000 to that in 2004?
Make the answer very short. 0.6. What is the ratio of the Aid recevied (constant 2012 US$) in Latvia in 2000 to that in 2004?
Give a very brief answer. 0.79. What is the ratio of the Aid recevied (constant 2012 US$) in Small states in 2001 to that in 2002?
Provide a succinct answer. 1.97. What is the ratio of the Aid recevied (constant 2012 US$) of Hong Kong in 2001 to that in 2002?
Your response must be concise. 0.86. What is the ratio of the Aid recevied (constant 2012 US$) of Latvia in 2001 to that in 2002?
Offer a very short reply. 1.52. What is the ratio of the Aid recevied (constant 2012 US$) in Small states in 2001 to that in 2003?
Keep it short and to the point. 2.39. What is the ratio of the Aid recevied (constant 2012 US$) in Hong Kong in 2001 to that in 2003?
Give a very brief answer. 0.73. What is the ratio of the Aid recevied (constant 2012 US$) in Latvia in 2001 to that in 2003?
Your answer should be compact. 1.23. What is the ratio of the Aid recevied (constant 2012 US$) of Small states in 2001 to that in 2004?
Offer a terse response. 2.01. What is the ratio of the Aid recevied (constant 2012 US$) in Hong Kong in 2001 to that in 2004?
Make the answer very short. 0.53. What is the ratio of the Aid recevied (constant 2012 US$) in Latvia in 2001 to that in 2004?
Your answer should be very brief. 0.96. What is the ratio of the Aid recevied (constant 2012 US$) in Small states in 2002 to that in 2003?
Give a very brief answer. 1.21. What is the ratio of the Aid recevied (constant 2012 US$) in Hong Kong in 2002 to that in 2003?
Provide a succinct answer. 0.85. What is the ratio of the Aid recevied (constant 2012 US$) in Latvia in 2002 to that in 2003?
Your response must be concise. 0.81. What is the ratio of the Aid recevied (constant 2012 US$) of Small states in 2002 to that in 2004?
Your answer should be very brief. 1.02. What is the ratio of the Aid recevied (constant 2012 US$) of Hong Kong in 2002 to that in 2004?
Your answer should be very brief. 0.61. What is the ratio of the Aid recevied (constant 2012 US$) in Latvia in 2002 to that in 2004?
Make the answer very short. 0.63. What is the ratio of the Aid recevied (constant 2012 US$) of Small states in 2003 to that in 2004?
Make the answer very short. 0.84. What is the ratio of the Aid recevied (constant 2012 US$) in Hong Kong in 2003 to that in 2004?
Your answer should be compact. 0.72. What is the ratio of the Aid recevied (constant 2012 US$) in Latvia in 2003 to that in 2004?
Provide a short and direct response. 0.78. What is the difference between the highest and the second highest Aid recevied (constant 2012 US$) in Small states?
Offer a very short reply. 1.57e+07. What is the difference between the highest and the second highest Aid recevied (constant 2012 US$) of Hong Kong?
Your answer should be very brief. 2.15e+06. What is the difference between the highest and the second highest Aid recevied (constant 2012 US$) of Latvia?
Offer a terse response. 8.60e+06. What is the difference between the highest and the lowest Aid recevied (constant 2012 US$) of Small states?
Offer a terse response. 2.81e+07. What is the difference between the highest and the lowest Aid recevied (constant 2012 US$) of Hong Kong?
Your response must be concise. 7.07e+06. What is the difference between the highest and the lowest Aid recevied (constant 2012 US$) in Latvia?
Your answer should be very brief. 7.48e+07. 